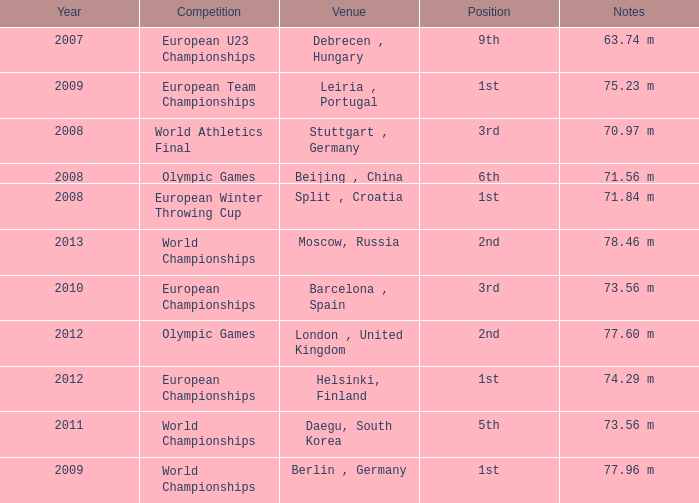What were the notes in 2011? 73.56 m. 